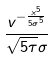Convert formula to latex. <formula><loc_0><loc_0><loc_500><loc_500>\frac { v ^ { - \frac { x ^ { 5 } } { 5 \sigma ^ { 5 } } } } { \sqrt { 5 \tau } \sigma }</formula> 